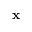<formula> <loc_0><loc_0><loc_500><loc_500>x</formula> 